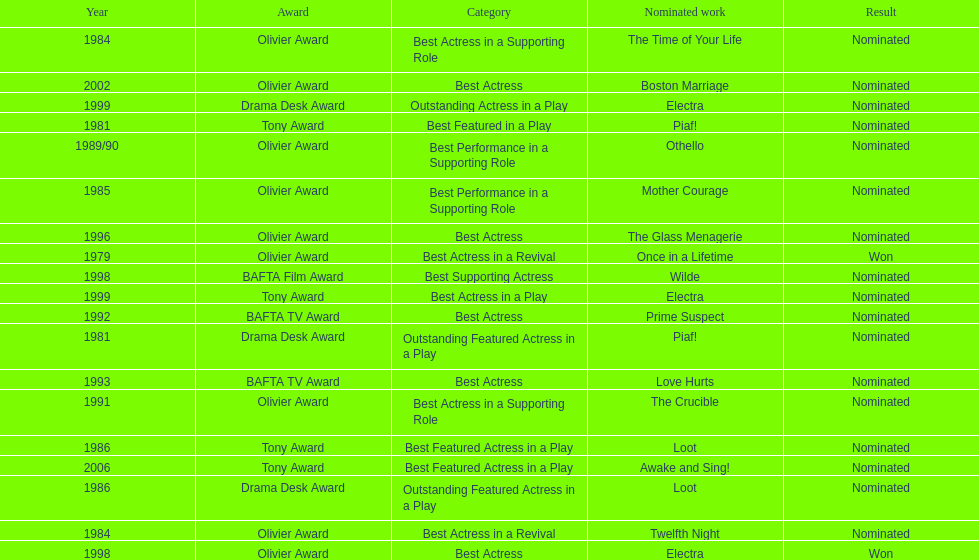What play was wanamaker nominated for best featured in a play in 1981? Piaf!. 